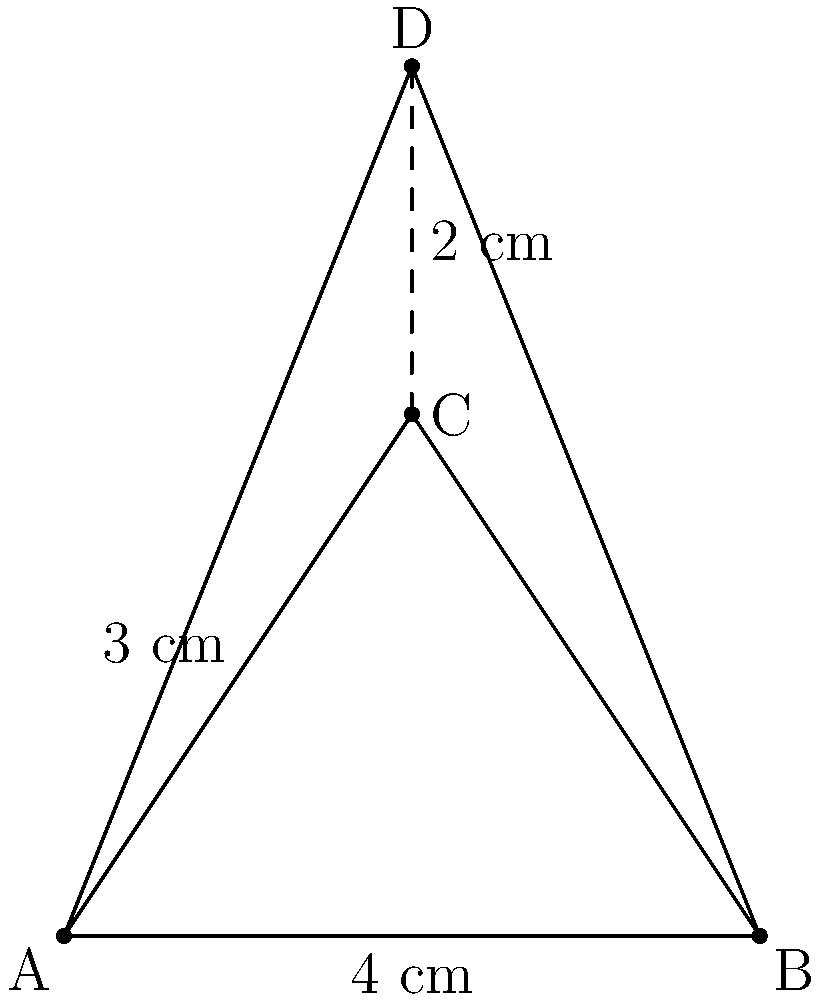You've designed a unique pyramid-shaped display stand for your novelty store's quirkiest items. The base is a triangle with sides 4 cm, and the height of the pyramid is 5 cm. If the slant height from the base to the apex is 5 cm, calculate the total surface area of the display stand. Round your answer to the nearest square centimeter. To find the total surface area, we need to calculate the area of the base and the area of the three triangular faces, then sum them up.

Step 1: Calculate the area of the base (equilateral triangle)
- Side length of the base (s) = 4 cm
- Area of equilateral triangle = $\frac{\sqrt{3}}{4}s^2$
- Base area = $\frac{\sqrt{3}}{4} \times 4^2 = 4\sqrt{3}$ cm²

Step 2: Calculate the area of one triangular face
- Base of the face = 4 cm
- Height of the face (slant height) = 5 cm
- Area of one face = $\frac{1}{2} \times 4 \times 5 = 10$ cm²

Step 3: Calculate the total surface area
- Total surface area = Base area + (3 × Face area)
- Total surface area = $4\sqrt{3} + (3 \times 10)$
- Total surface area = $4\sqrt{3} + 30$ cm²

Step 4: Simplify and round to the nearest square centimeter
- $4\sqrt{3} \approx 6.93$
- Total surface area ≈ 6.93 + 30 = 36.93 cm²
- Rounded to the nearest square centimeter: 37 cm²
Answer: 37 cm² 